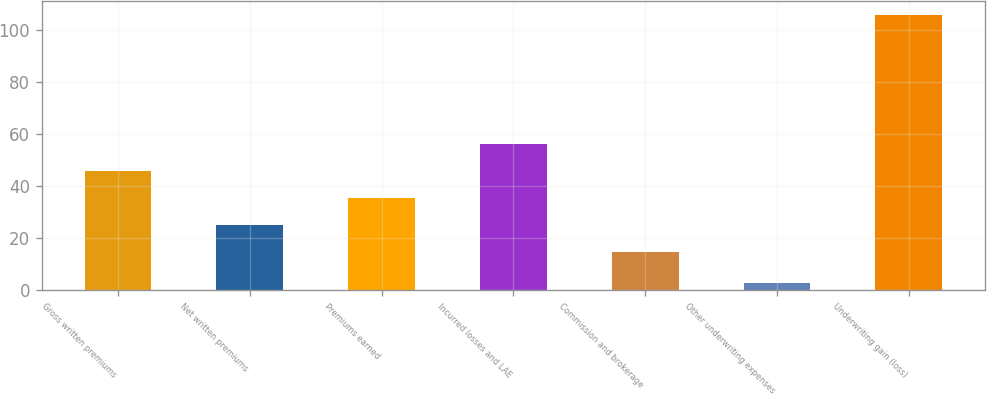<chart> <loc_0><loc_0><loc_500><loc_500><bar_chart><fcel>Gross written premiums<fcel>Net written premiums<fcel>Premiums earned<fcel>Incurred losses and LAE<fcel>Commission and brokerage<fcel>Other underwriting expenses<fcel>Underwriting gain (loss)<nl><fcel>45.83<fcel>25.21<fcel>35.52<fcel>56.14<fcel>14.9<fcel>2.9<fcel>106<nl></chart> 